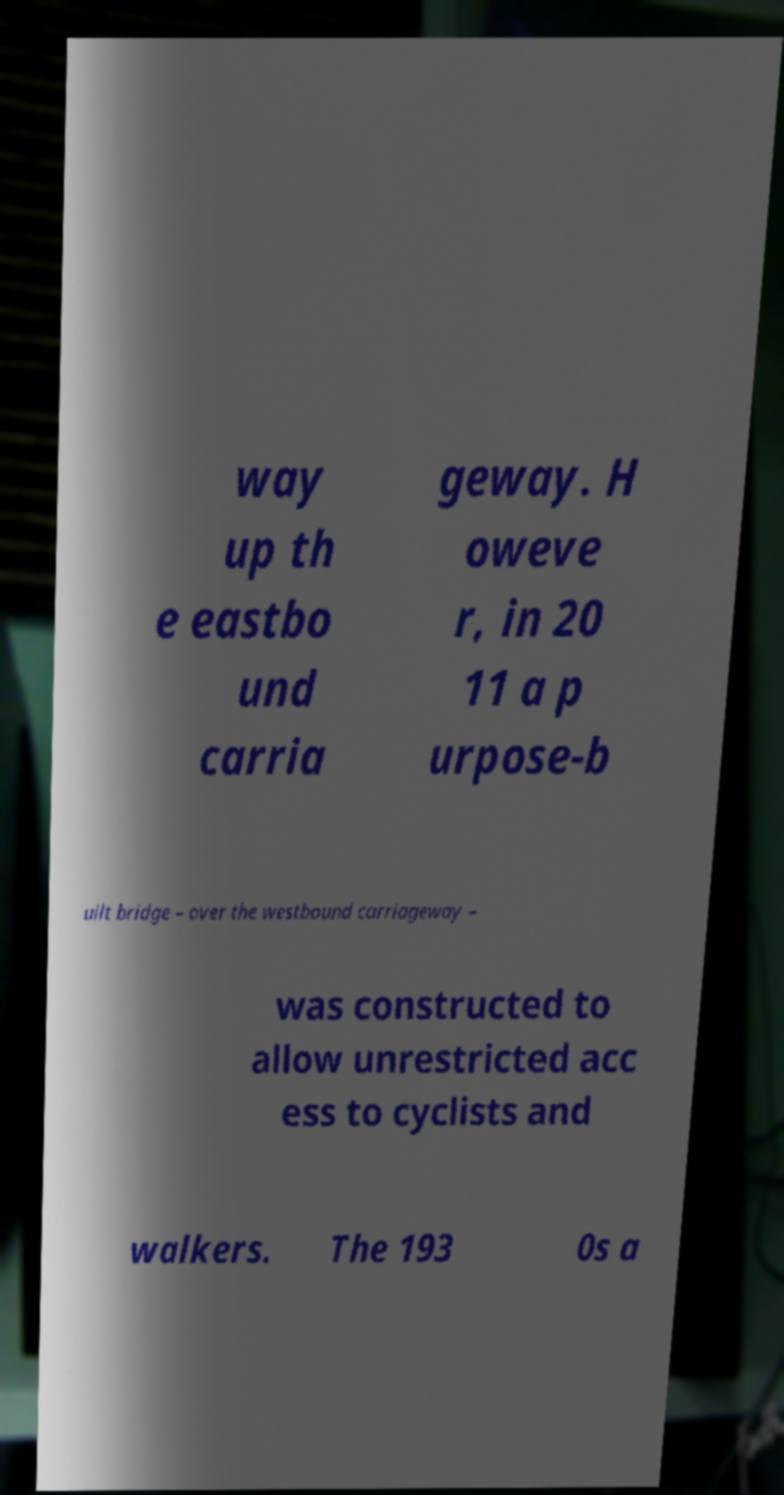For documentation purposes, I need the text within this image transcribed. Could you provide that? way up th e eastbo und carria geway. H oweve r, in 20 11 a p urpose-b uilt bridge – over the westbound carriageway – was constructed to allow unrestricted acc ess to cyclists and walkers. The 193 0s a 